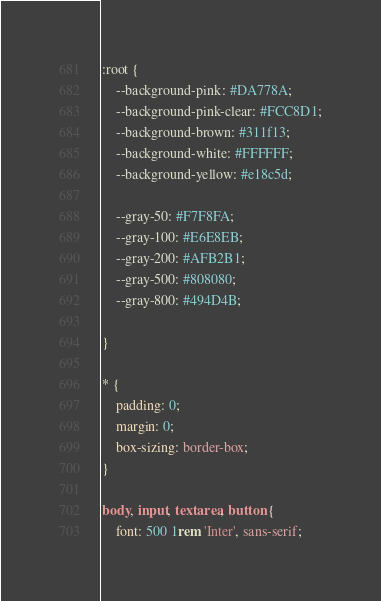Convert code to text. <code><loc_0><loc_0><loc_500><loc_500><_CSS_>:root { 
    --background-pink: #DA778A;
    --background-pink-clear: #FCC8D1;
    --background-brown: #311f13;
    --background-white: #FFFFFF;
    --background-yellow: #e18c5d;

    --gray-50: #F7F8FA;
    --gray-100: #E6E8EB;
    --gray-200: #AFB2B1;
    --gray-500: #808080;
    --gray-800: #494D4B;

}

* {
    padding: 0;
    margin: 0;
    box-sizing: border-box;
}

body, input, textarea, button {
    font: 500 1rem 'Inter', sans-serif;</code> 